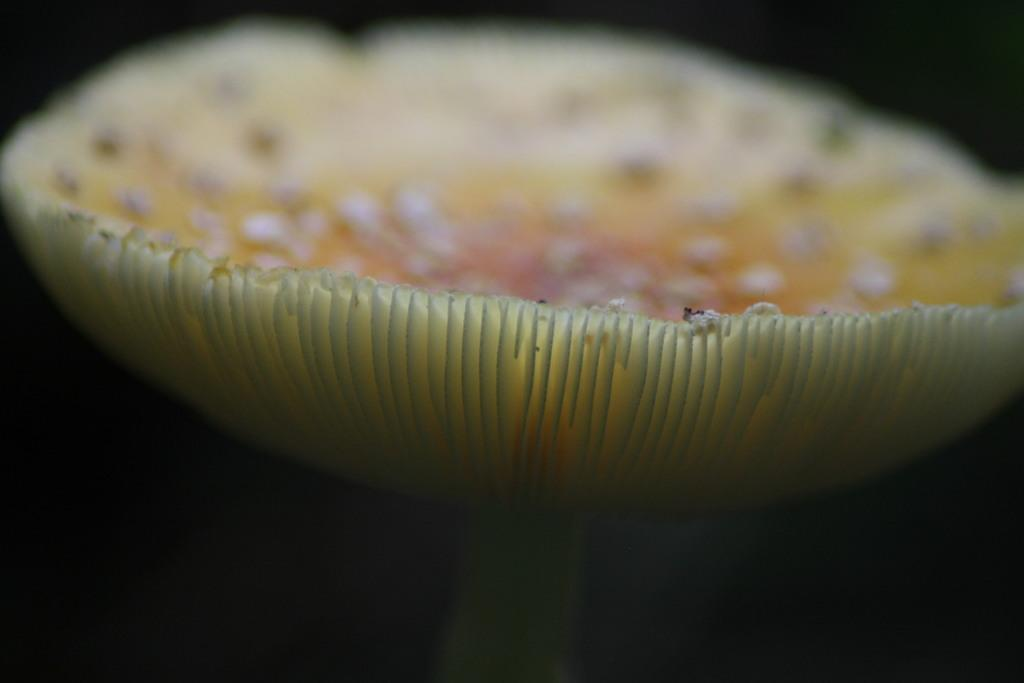What is the main subject of the image? There is an object that resembles a mushroom in the image. How would you describe the background of the image? The background of the image is blurred and dark in color. What sense of approval or hope does the mushroom convey in the image? The image does not convey any sense of approval or hope, as it only features a mushroom-like object and a blurred, dark background. 